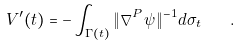Convert formula to latex. <formula><loc_0><loc_0><loc_500><loc_500>V ^ { \prime } ( t ) = - \int _ { \Gamma ( t ) } \| \nabla ^ { P } \psi \| ^ { - 1 } d \sigma _ { t } \quad .</formula> 